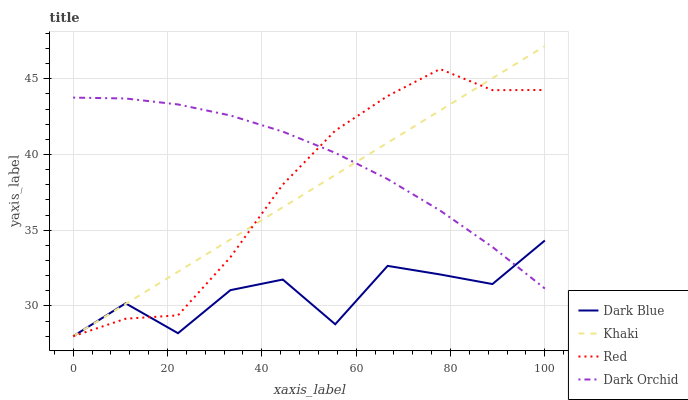Does Dark Blue have the minimum area under the curve?
Answer yes or no. Yes. Does Dark Orchid have the maximum area under the curve?
Answer yes or no. Yes. Does Khaki have the minimum area under the curve?
Answer yes or no. No. Does Khaki have the maximum area under the curve?
Answer yes or no. No. Is Khaki the smoothest?
Answer yes or no. Yes. Is Dark Blue the roughest?
Answer yes or no. Yes. Is Dark Orchid the smoothest?
Answer yes or no. No. Is Dark Orchid the roughest?
Answer yes or no. No. Does Dark Orchid have the lowest value?
Answer yes or no. No. Does Khaki have the highest value?
Answer yes or no. Yes. Does Dark Orchid have the highest value?
Answer yes or no. No. 